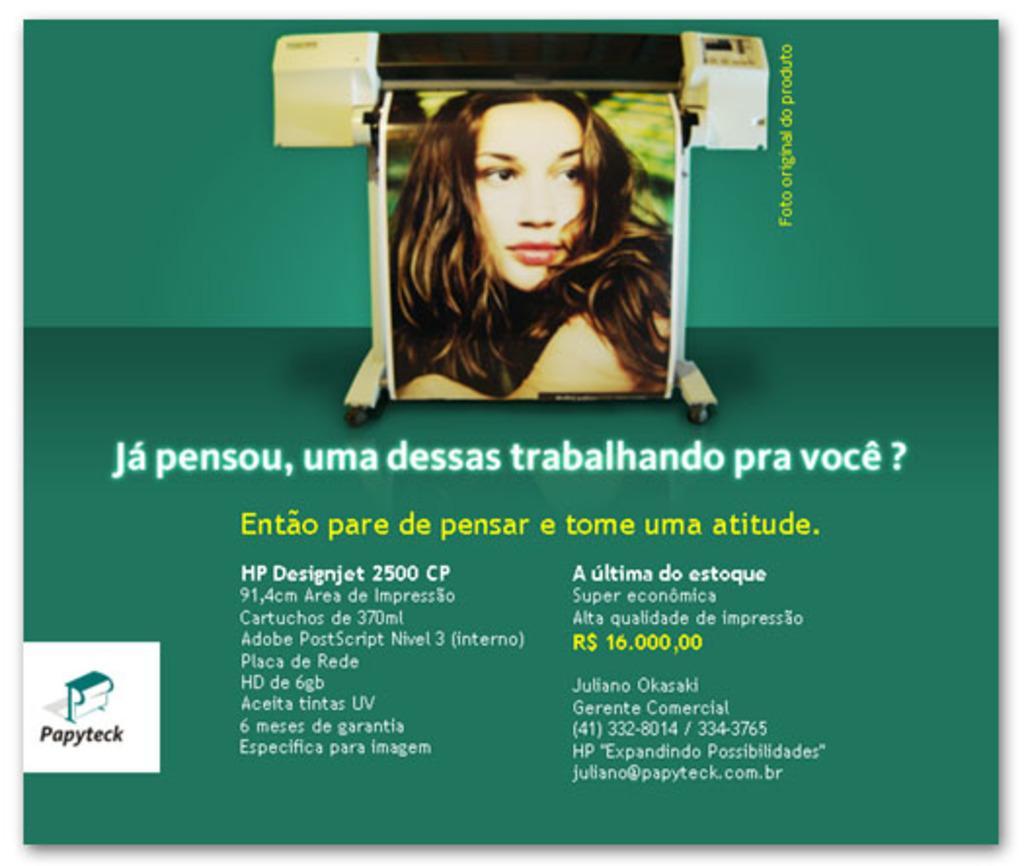Can you describe this image briefly? In this image we can see a poster, on that there is a picture of a woman, also we can see some text on it. 